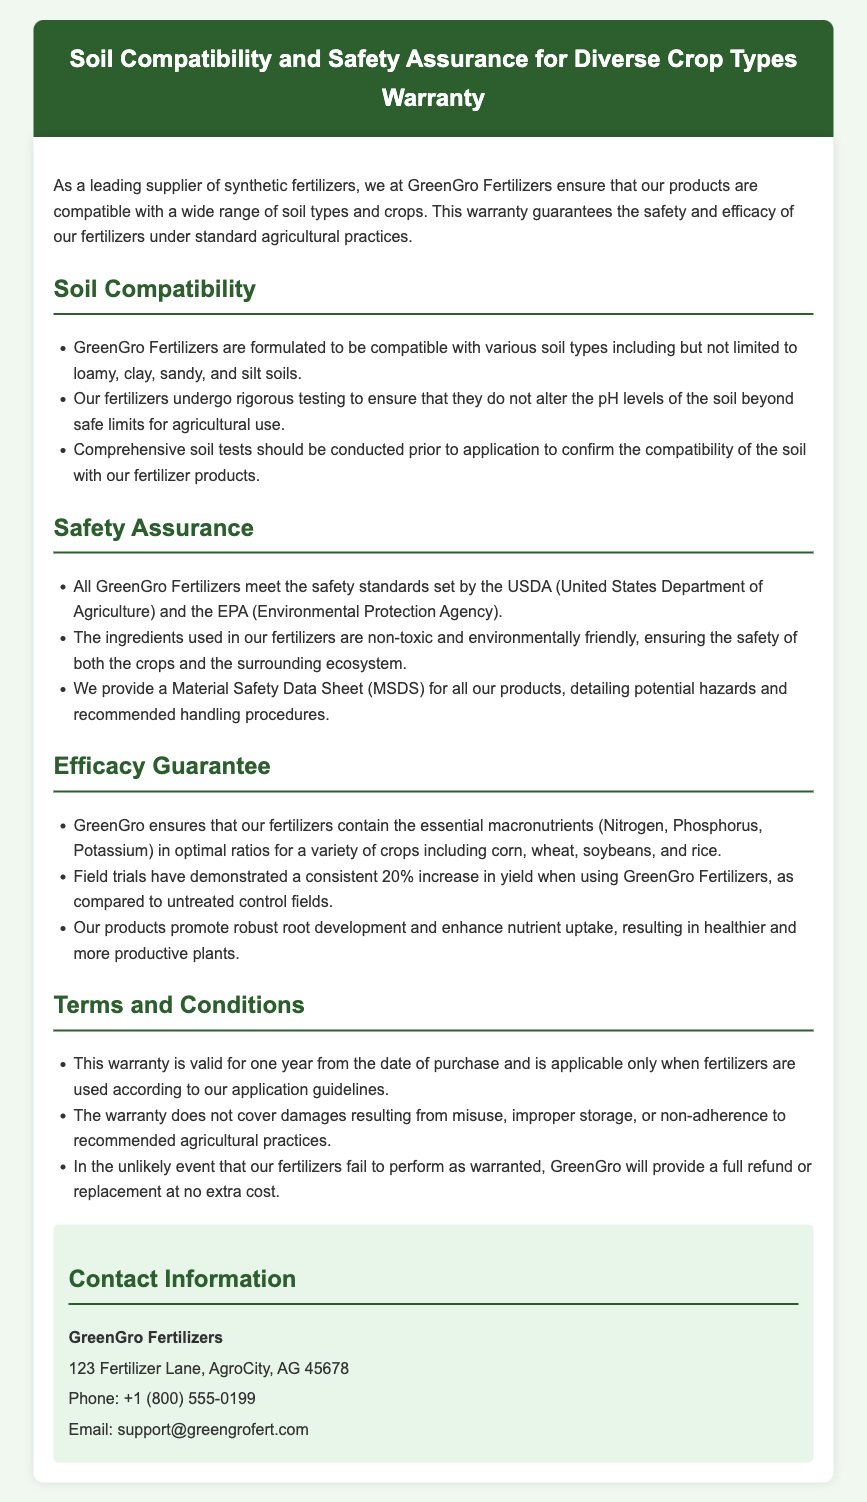What is the warranty duration? The warranty is valid for one year from the date of purchase.
Answer: one year Which regulatory standards do GreenGro Fertilizers meet? The document states that all GreenGro Fertilizers meet the safety standards set by the USDA and the EPA.
Answer: USDA and EPA What types of soils are mentioned as compatible with GreenGro Fertilizers? The document lists loamy, clay, sandy, and silt soils as compatible.
Answer: loamy, clay, sandy, and silt What ingredient ratios do GreenGro Fertilizers contain for crops? The fertilizers contain essential macronutrients in optimal ratios, specifically listed as Nitrogen, Phosphorus, and Potassium.
Answer: Nitrogen, Phosphorus, Potassium How much yield increase does GreenGro claim from their fertilizers? The document mentions a consistent 20% increase in yield compared to untreated control fields.
Answer: 20% What should be conducted prior to fertilizer application? The warranty advises conducting comprehensive soil tests before application.
Answer: comprehensive soil tests What will GreenGro provide if their fertilizers fail to perform? In such an event, GreenGro will provide a full refund or replacement at no extra cost.
Answer: full refund or replacement What is provided for all GreenGro products detailing potential hazards? A Material Safety Data Sheet (MSDS) is provided for all products.
Answer: Material Safety Data Sheet (MSDS) 